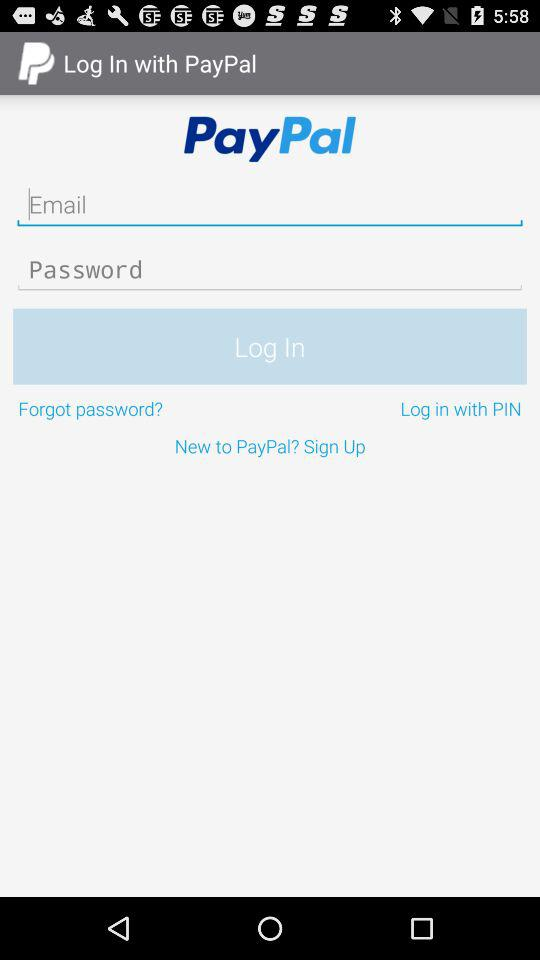What is the app name? The app name is "PayPal". 